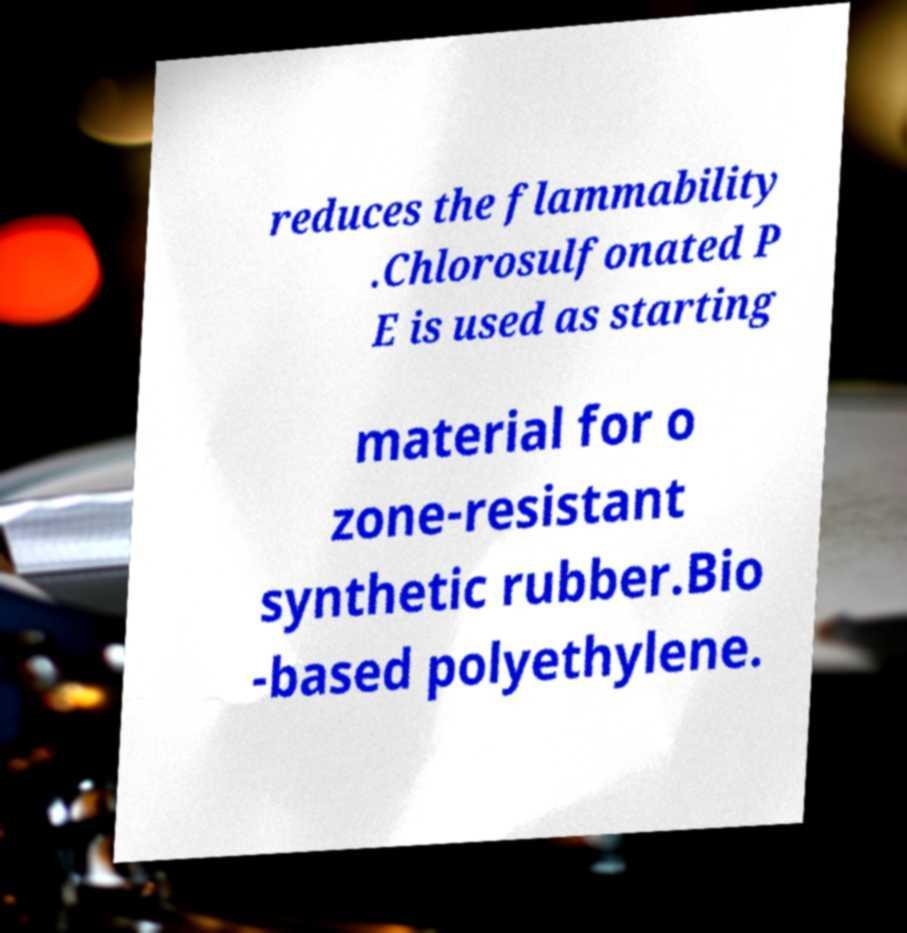Can you accurately transcribe the text from the provided image for me? reduces the flammability .Chlorosulfonated P E is used as starting material for o zone-resistant synthetic rubber.Bio -based polyethylene. 